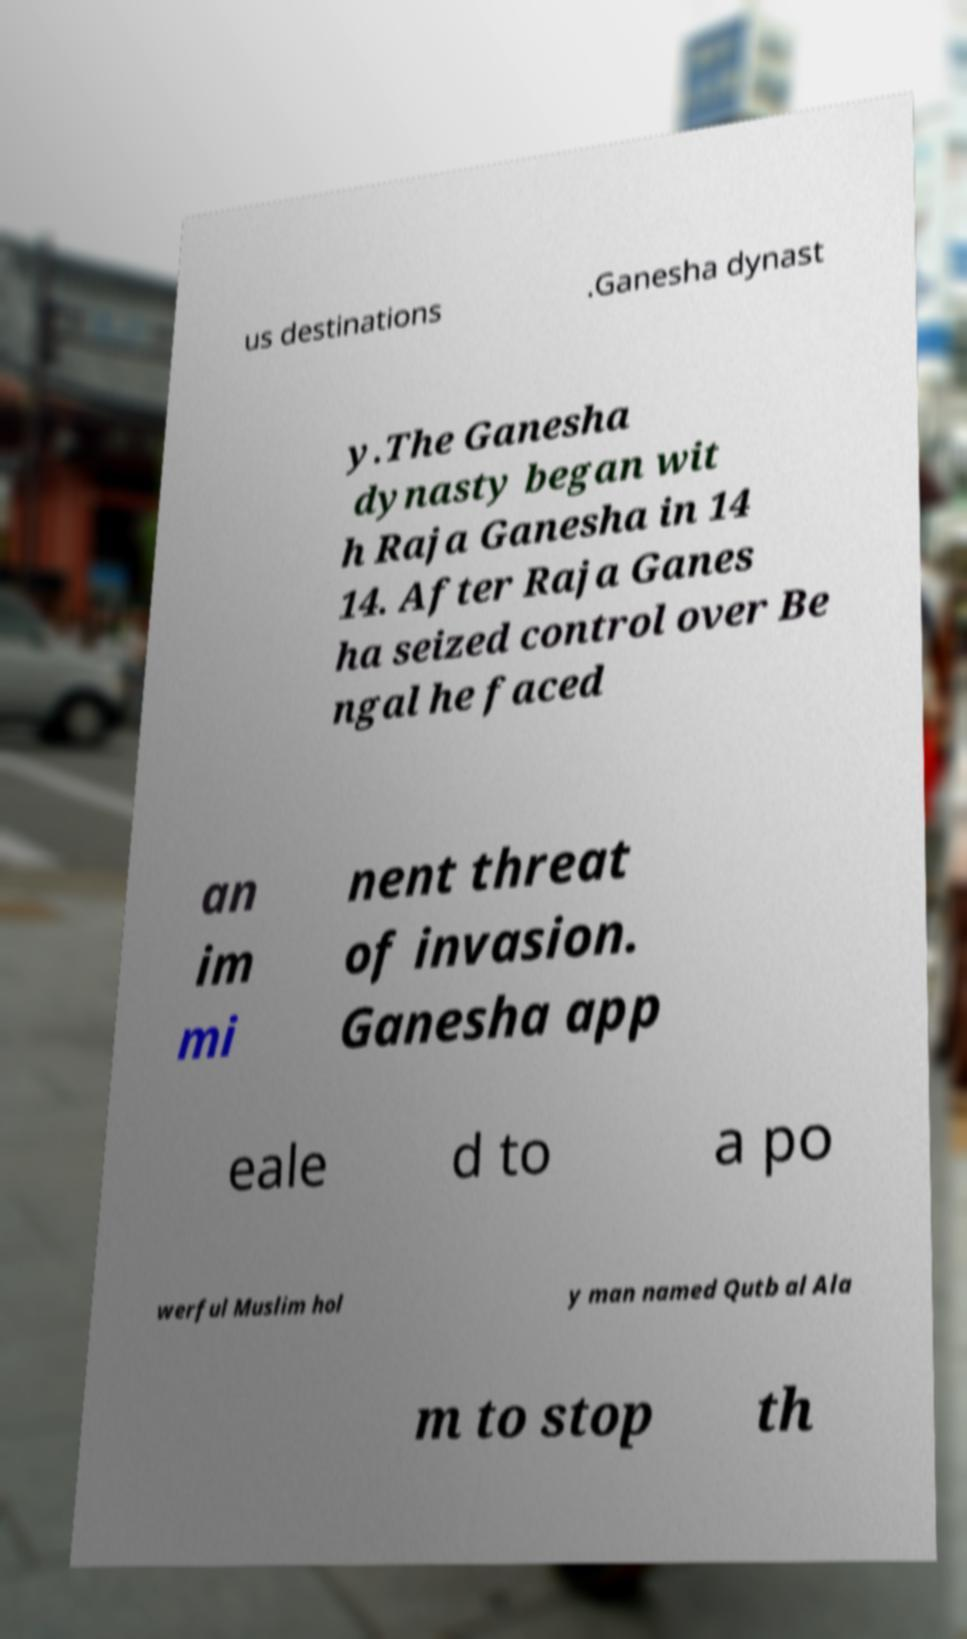Could you assist in decoding the text presented in this image and type it out clearly? us destinations .Ganesha dynast y.The Ganesha dynasty began wit h Raja Ganesha in 14 14. After Raja Ganes ha seized control over Be ngal he faced an im mi nent threat of invasion. Ganesha app eale d to a po werful Muslim hol y man named Qutb al Ala m to stop th 